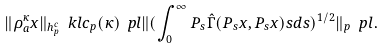Convert formula to latex. <formula><loc_0><loc_0><loc_500><loc_500>\| \rho _ { a } ^ { \kappa } x \| _ { h _ { p } ^ { c } } \ k l c _ { p } ( \kappa ) \ p l \| ( \int _ { 0 } ^ { \infty } P _ { s } \hat { \Gamma } ( P _ { s } x , P _ { s } x ) s d s ) ^ { 1 / 2 } \| _ { p } \ p l .</formula> 